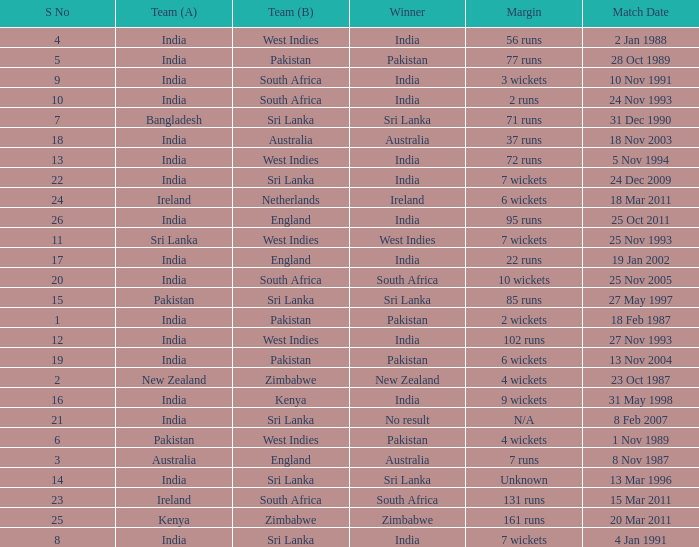How many games were won by a margin of 131 runs? 1.0. 